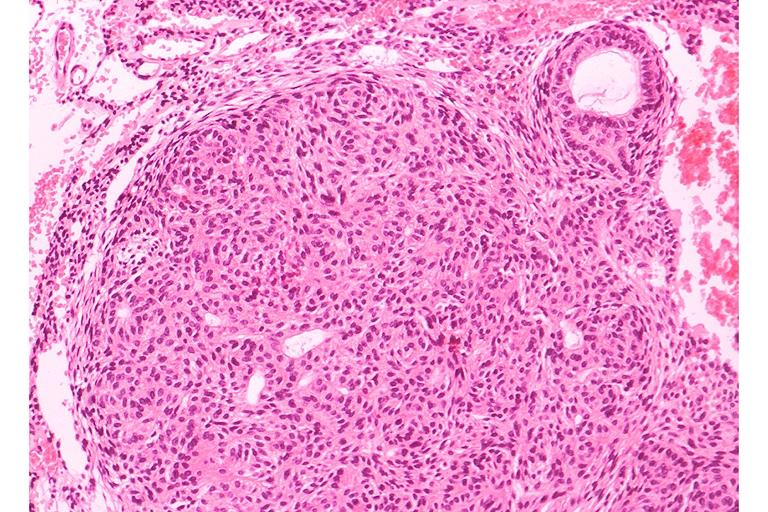does temporal muscle hemorrhage show adenomatoid odontogenic tumor?
Answer the question using a single word or phrase. No 